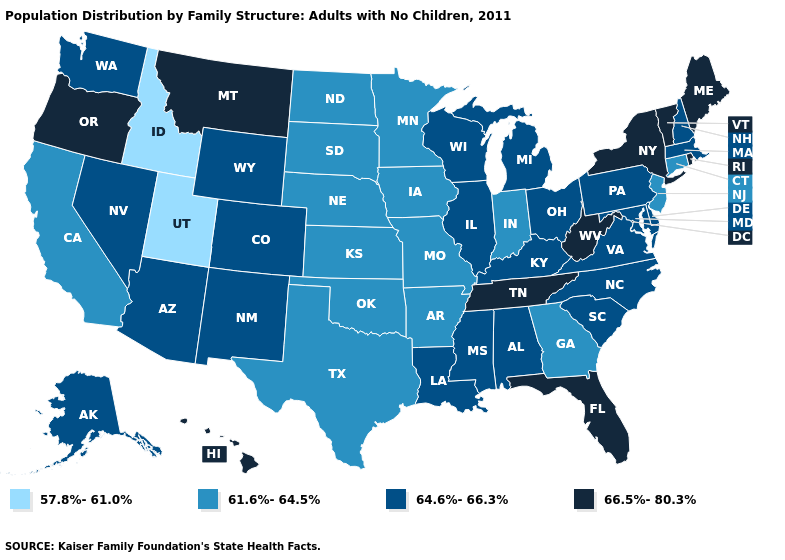Among the states that border Utah , does Colorado have the highest value?
Write a very short answer. Yes. Among the states that border Pennsylvania , does New York have the lowest value?
Quick response, please. No. Name the states that have a value in the range 66.5%-80.3%?
Concise answer only. Florida, Hawaii, Maine, Montana, New York, Oregon, Rhode Island, Tennessee, Vermont, West Virginia. Name the states that have a value in the range 57.8%-61.0%?
Write a very short answer. Idaho, Utah. Does Utah have the lowest value in the USA?
Short answer required. Yes. What is the value of Michigan?
Keep it brief. 64.6%-66.3%. What is the value of West Virginia?
Be succinct. 66.5%-80.3%. How many symbols are there in the legend?
Quick response, please. 4. Does Minnesota have a higher value than Utah?
Write a very short answer. Yes. What is the lowest value in states that border Indiana?
Give a very brief answer. 64.6%-66.3%. Name the states that have a value in the range 61.6%-64.5%?
Answer briefly. Arkansas, California, Connecticut, Georgia, Indiana, Iowa, Kansas, Minnesota, Missouri, Nebraska, New Jersey, North Dakota, Oklahoma, South Dakota, Texas. Which states have the highest value in the USA?
Concise answer only. Florida, Hawaii, Maine, Montana, New York, Oregon, Rhode Island, Tennessee, Vermont, West Virginia. What is the lowest value in states that border West Virginia?
Write a very short answer. 64.6%-66.3%. Does Michigan have the lowest value in the MidWest?
Keep it brief. No. Which states have the highest value in the USA?
Be succinct. Florida, Hawaii, Maine, Montana, New York, Oregon, Rhode Island, Tennessee, Vermont, West Virginia. 